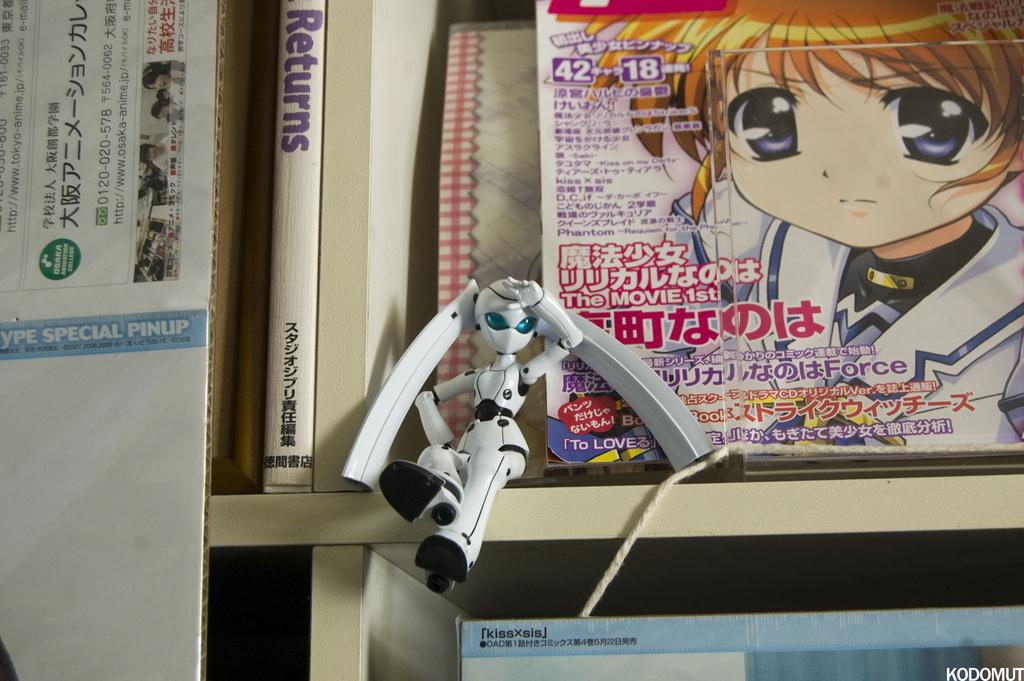<image>
Describe the image concisely. A doll sits on a shelf in front of an anime magazine with Japanese text on it next to the doll is a book with the title RETURNS. 